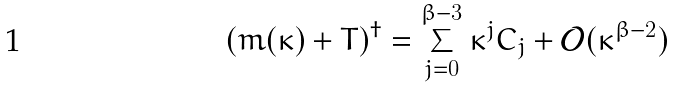Convert formula to latex. <formula><loc_0><loc_0><loc_500><loc_500>( m ( \kappa ) + T ) ^ { \dagger } = \sum _ { j = 0 } ^ { \beta - 3 } \kappa ^ { j } C _ { j } + \mathcal { O } ( \kappa ^ { \beta - 2 } )</formula> 